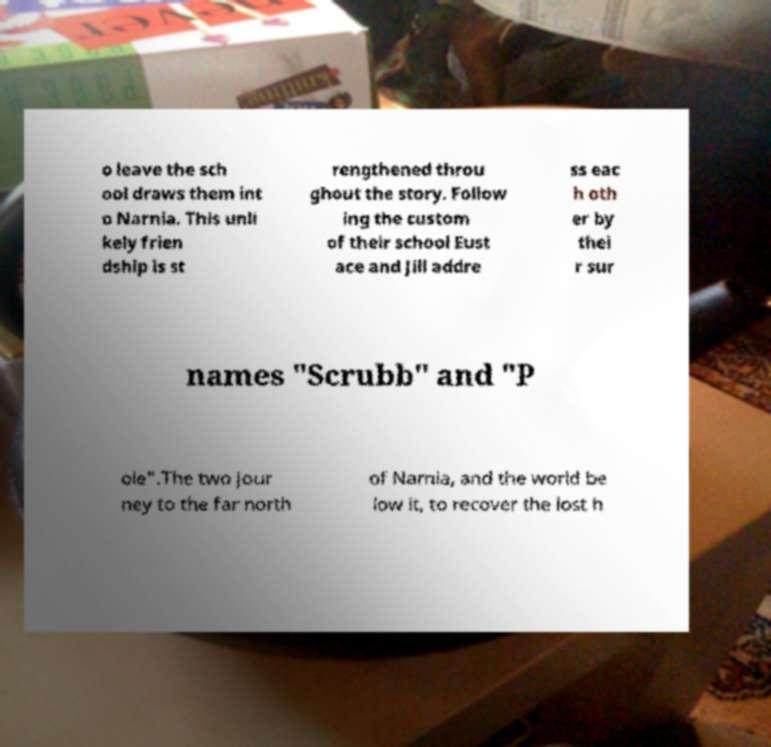Please read and relay the text visible in this image. What does it say? o leave the sch ool draws them int o Narnia. This unli kely frien dship is st rengthened throu ghout the story. Follow ing the custom of their school Eust ace and Jill addre ss eac h oth er by thei r sur names "Scrubb" and "P ole".The two jour ney to the far north of Narnia, and the world be low it, to recover the lost h 